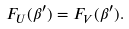Convert formula to latex. <formula><loc_0><loc_0><loc_500><loc_500>F _ { U } ( \beta ^ { \prime } ) = F _ { V } ( \beta ^ { \prime } ) .</formula> 